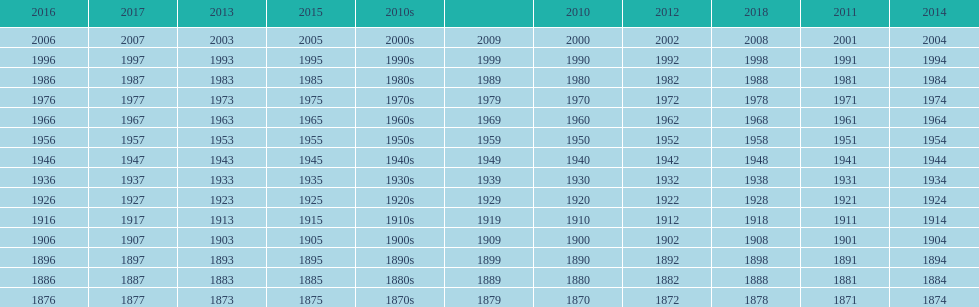True/false: all years go in consecutive order? True. 